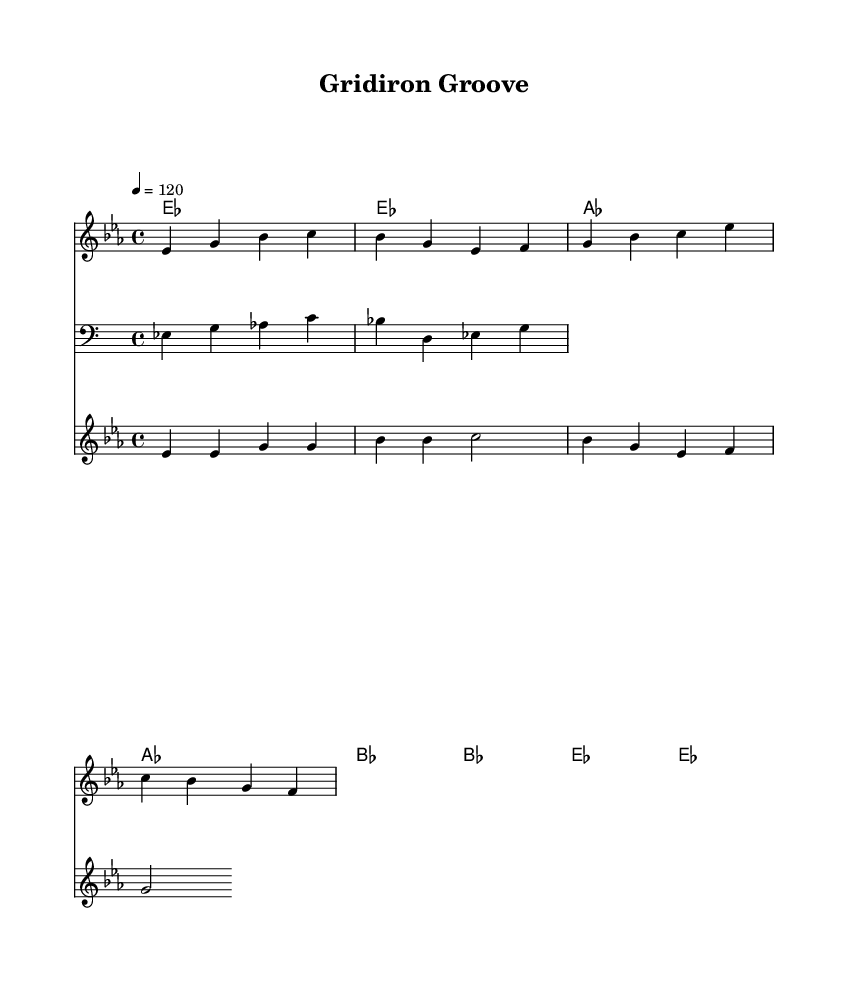What is the key signature of this music? The key signature, located at the beginning of the staff, shows two flats, which indicates it is in the key of E flat major.
Answer: E flat major What is the time signature of this music? The time signature, found at the beginning of the composition, is indicated as 4/4, meaning there are four beats in each measure and the quarter note gets one beat.
Answer: 4/4 What is the tempo marking of this music? The tempo marking indicates a speed of 120 beats per minute, represented by the number "120" in a quarter note=notation format, which suggests a moderate pace for the piece.
Answer: 120 How many measures are in the melody? By counting the individual segments separated by vertical lines (bars), there are four measures in the melody section of the sheet music.
Answer: 4 Which instrument plays the bassline? The bassline is indicated by the clef labeled "bass" at the beginning of the staff, designating that it is meant to be played by a bass instrument.
Answer: Bass What is the title of this piece? The title of the piece, which is typically found at the top of the sheet music, is "Gridiron Groove."
Answer: Gridiron Groove What kind of rhythmic feel is predominantly used in this track? The rhythmic feel is characterized by syncopation and a strong backbeat typical of funk and R&B music, which is evident in the catchy hooks and bassline.
Answer: Funk-infused R&B 